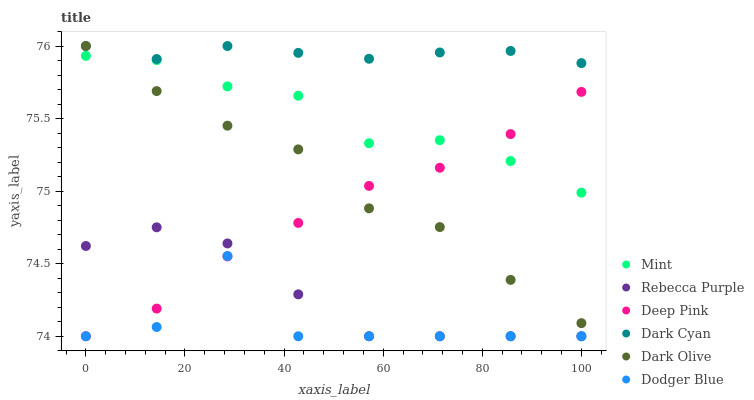Does Dodger Blue have the minimum area under the curve?
Answer yes or no. Yes. Does Dark Cyan have the maximum area under the curve?
Answer yes or no. Yes. Does Dark Olive have the minimum area under the curve?
Answer yes or no. No. Does Dark Olive have the maximum area under the curve?
Answer yes or no. No. Is Dark Cyan the smoothest?
Answer yes or no. Yes. Is Dodger Blue the roughest?
Answer yes or no. Yes. Is Dark Olive the smoothest?
Answer yes or no. No. Is Dark Olive the roughest?
Answer yes or no. No. Does Deep Pink have the lowest value?
Answer yes or no. Yes. Does Dark Olive have the lowest value?
Answer yes or no. No. Does Dark Cyan have the highest value?
Answer yes or no. Yes. Does Dodger Blue have the highest value?
Answer yes or no. No. Is Dodger Blue less than Dark Cyan?
Answer yes or no. Yes. Is Dark Cyan greater than Rebecca Purple?
Answer yes or no. Yes. Does Deep Pink intersect Rebecca Purple?
Answer yes or no. Yes. Is Deep Pink less than Rebecca Purple?
Answer yes or no. No. Is Deep Pink greater than Rebecca Purple?
Answer yes or no. No. Does Dodger Blue intersect Dark Cyan?
Answer yes or no. No. 